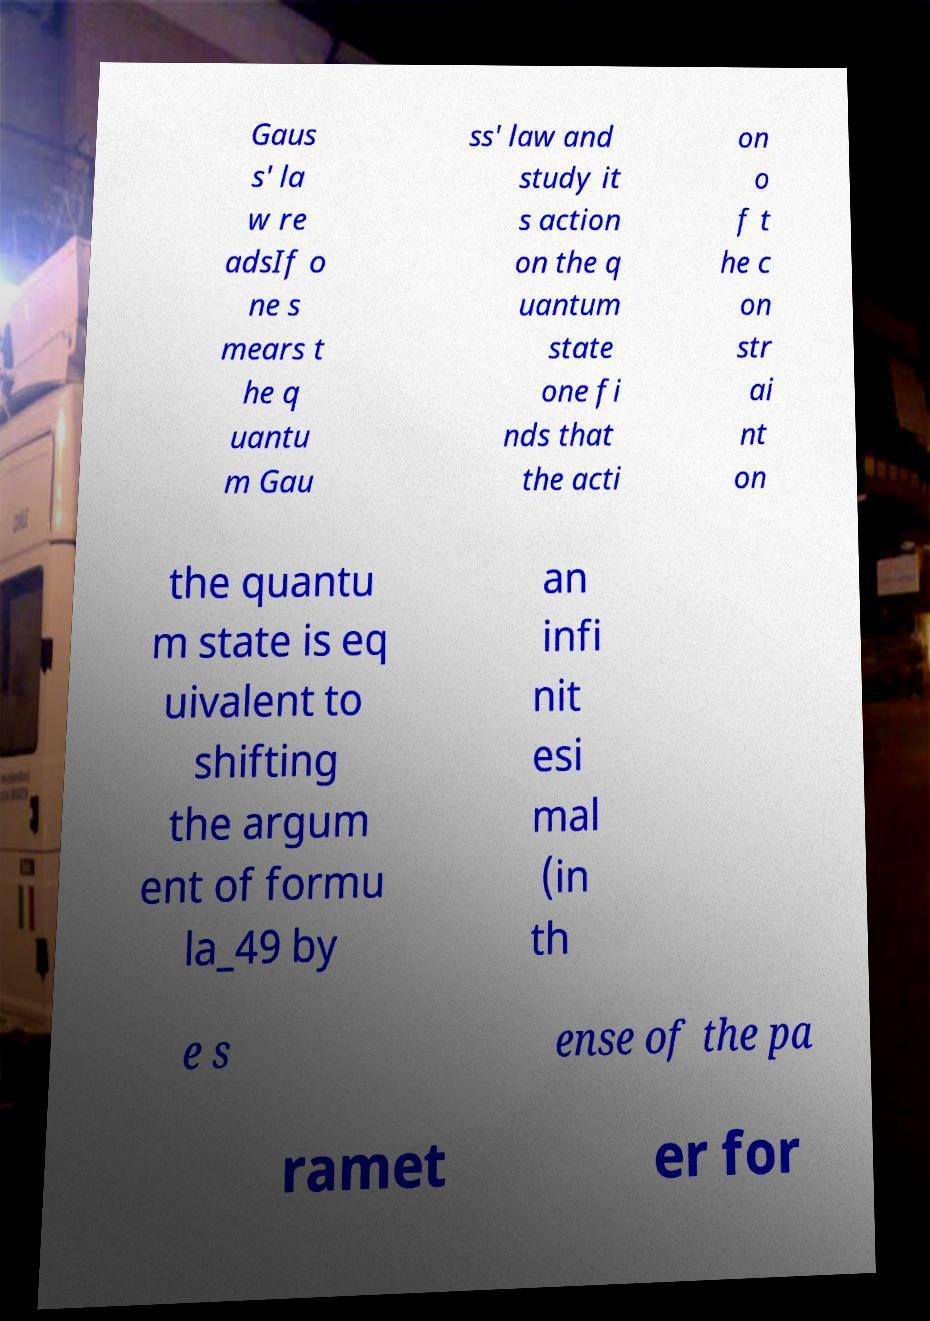Could you assist in decoding the text presented in this image and type it out clearly? Gaus s' la w re adsIf o ne s mears t he q uantu m Gau ss' law and study it s action on the q uantum state one fi nds that the acti on o f t he c on str ai nt on the quantu m state is eq uivalent to shifting the argum ent of formu la_49 by an infi nit esi mal (in th e s ense of the pa ramet er for 